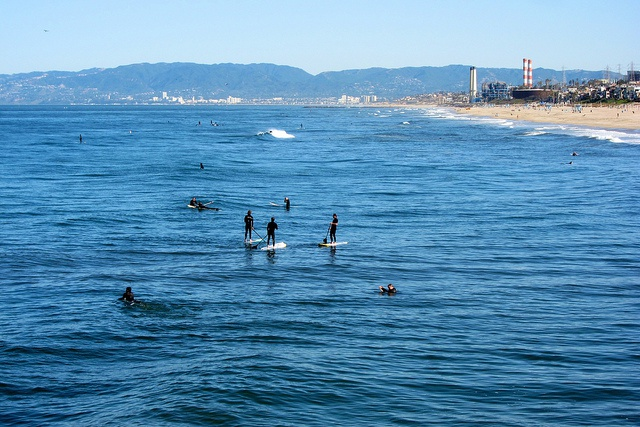Describe the objects in this image and their specific colors. I can see people in lightblue, tan, gray, and lightgray tones, people in lightblue, black, navy, and blue tones, people in lightblue, black, darkblue, and teal tones, people in lightblue, black, blue, navy, and lightgray tones, and people in lightblue, black, gray, and darkblue tones in this image. 